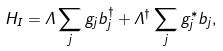<formula> <loc_0><loc_0><loc_500><loc_500>H _ { I } = \Lambda \sum _ { j } g _ { j } b _ { j } ^ { \dagger } + \Lambda ^ { \dagger } \sum _ { j } g _ { j } ^ { \ast } b _ { j } ,</formula> 